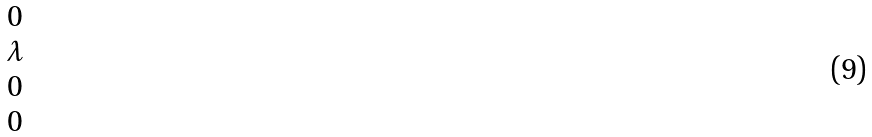<formula> <loc_0><loc_0><loc_500><loc_500>\begin{matrix} 0 \\ \lambda \\ 0 \\ 0 \end{matrix}</formula> 